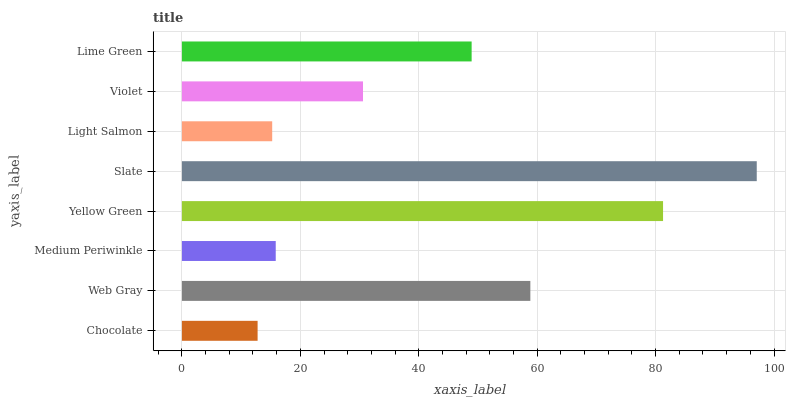Is Chocolate the minimum?
Answer yes or no. Yes. Is Slate the maximum?
Answer yes or no. Yes. Is Web Gray the minimum?
Answer yes or no. No. Is Web Gray the maximum?
Answer yes or no. No. Is Web Gray greater than Chocolate?
Answer yes or no. Yes. Is Chocolate less than Web Gray?
Answer yes or no. Yes. Is Chocolate greater than Web Gray?
Answer yes or no. No. Is Web Gray less than Chocolate?
Answer yes or no. No. Is Lime Green the high median?
Answer yes or no. Yes. Is Violet the low median?
Answer yes or no. Yes. Is Violet the high median?
Answer yes or no. No. Is Web Gray the low median?
Answer yes or no. No. 